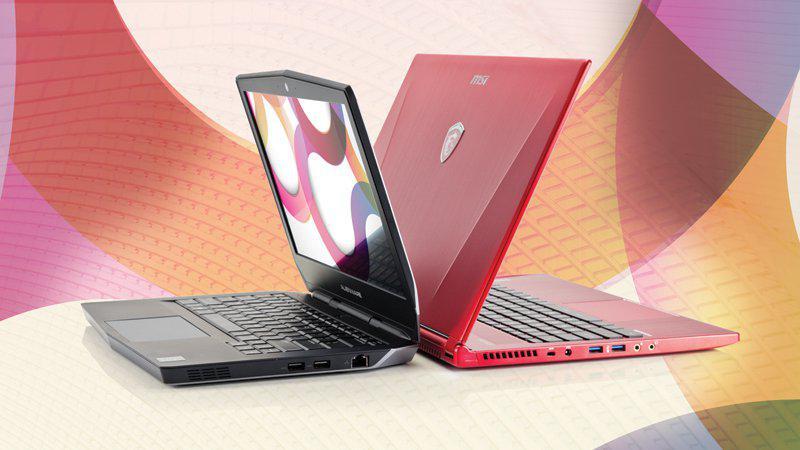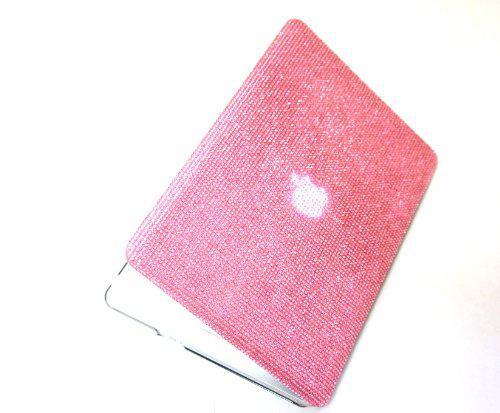The first image is the image on the left, the second image is the image on the right. For the images shown, is this caption "An image shows an open red device and a device with a patterned cover posed back-to-back in front of rows of closed devices." true? Answer yes or no. No. The first image is the image on the left, the second image is the image on the right. Evaluate the accuracy of this statement regarding the images: "A person's hand is near a digital device.". Is it true? Answer yes or no. No. 